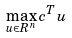<formula> <loc_0><loc_0><loc_500><loc_500>\max _ { u \in R ^ { n } } c ^ { T } u</formula> 